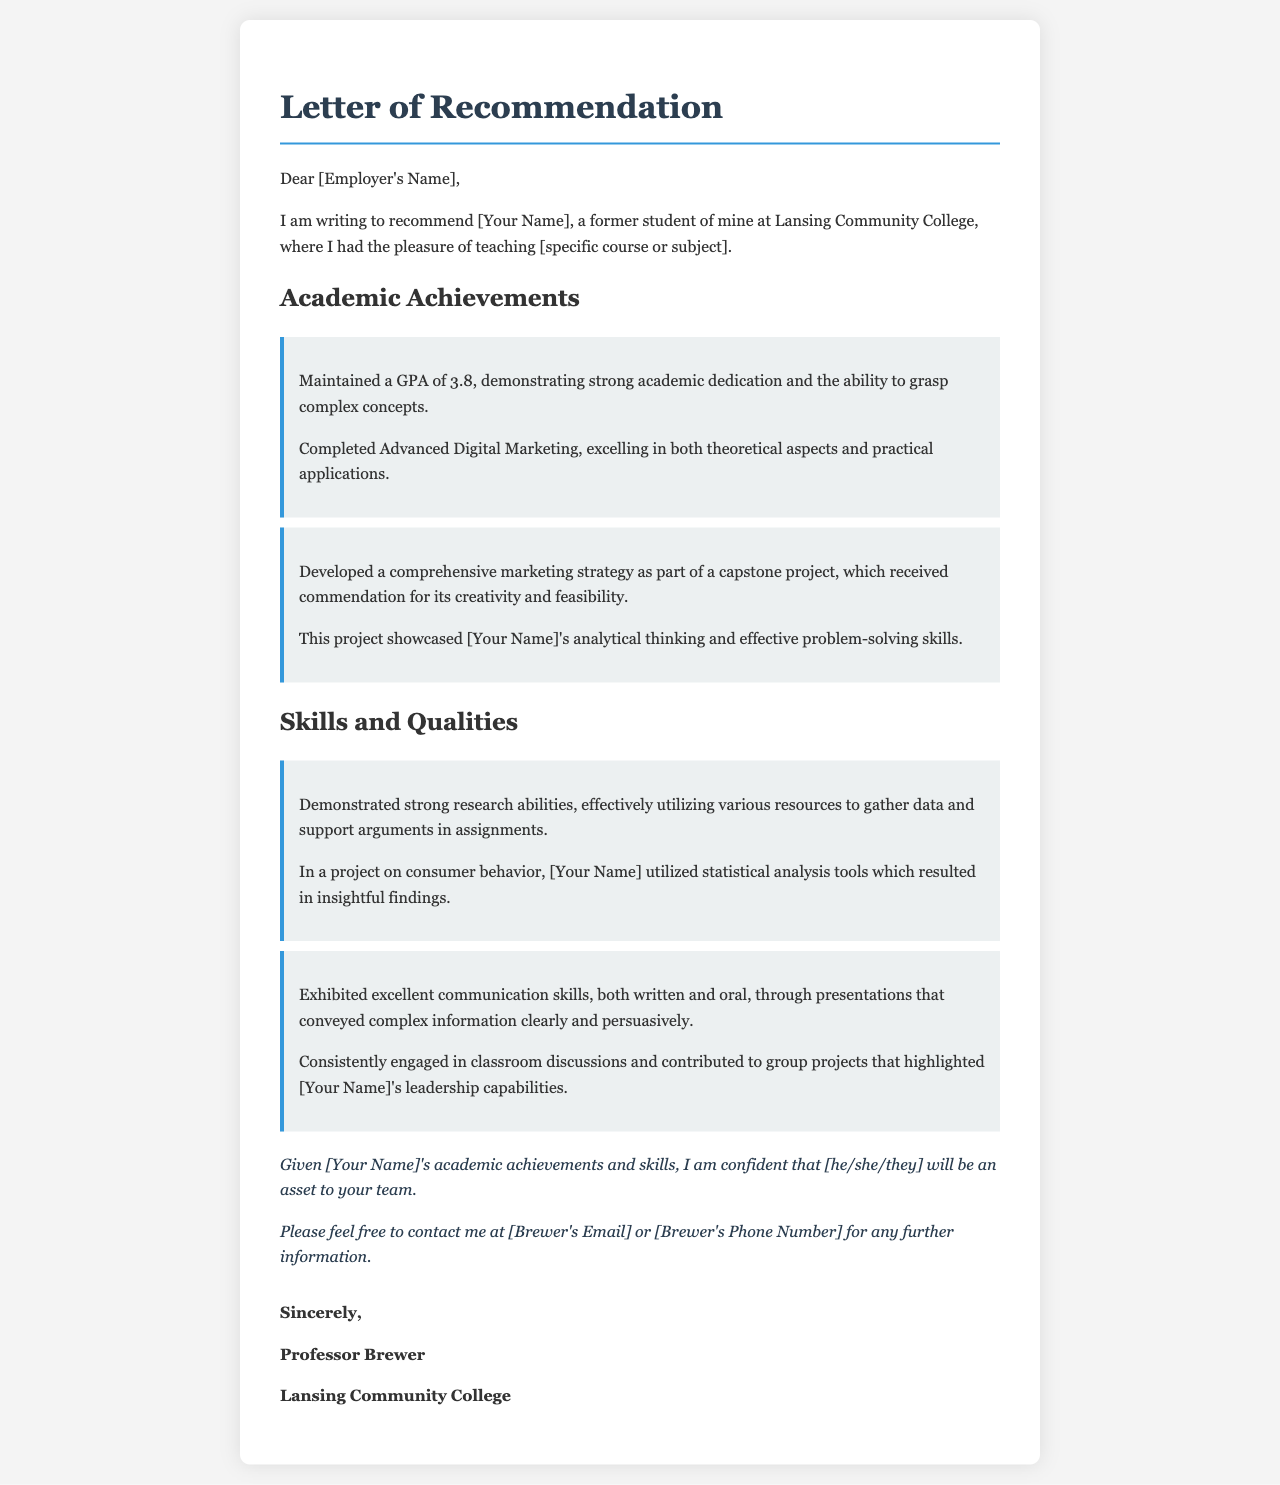what is the GPA of [Your Name]? The GPA of [Your Name] is mentioned in the section on Academic Achievements, indicating strong academic dedication.
Answer: 3.8 what course did Brewer teach? The letter states that Brewer taught a specific course or subject at Lansing Community College.
Answer: [specific course or subject] what type of project did [Your Name] develop? The document highlights that [Your Name] developed a marketing strategy as part of a capstone project which was well-received.
Answer: marketing strategy which skills are highlighted under Skills and Qualities? The letter mentions strong research abilities and excellent communication skills as key skills and qualities of [Your Name].
Answer: research abilities and communication skills who is the author of the letter? The signature at the end of the letter provides the name of the professor who authored the recommendation.
Answer: Professor Brewer what is notable about [Your Name]'s marketing strategy project? The project is specifically indicated as being commended for creativity and feasibility, showcasing analytical thinking.
Answer: creativity and feasibility how did [Your Name] utilize statistical analysis tools? The letter specifies that [Your Name] utilized these tools in a project on consumer behavior, leading to insightful findings.
Answer: consumer behavior what is the conclusion stated about [Your Name]? The conclusion emphasizes confidence in [Your Name] being an asset to the team based on achievements and skills.
Answer: an asset to your team what contact information is provided for further information? The document suggests contacting Brewer for further information, implying there are specific contact details included.
Answer: [Brewer's Email] or [Brewer's Phone Number] 